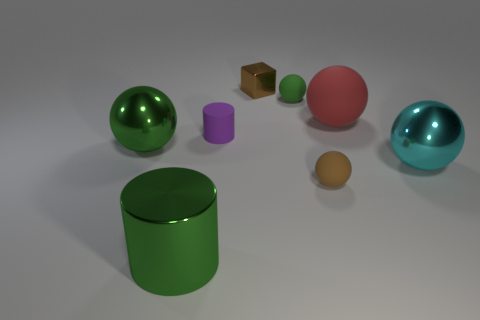What material is the big green object that is the same shape as the purple rubber thing?
Make the answer very short. Metal. Is the number of tiny purple rubber cylinders greater than the number of brown things?
Your response must be concise. No. How many other objects are the same color as the small block?
Provide a succinct answer. 1. Does the large red thing have the same material as the big sphere on the left side of the tiny brown rubber thing?
Your response must be concise. No. There is a small ball that is on the right side of the small matte ball that is behind the cyan metallic object; what number of metal objects are right of it?
Keep it short and to the point. 1. Is the number of cyan objects that are in front of the tiny purple matte object less than the number of metal objects that are on the right side of the green metallic ball?
Give a very brief answer. Yes. How many other things are the same material as the cyan object?
Your answer should be compact. 3. What material is the cyan sphere that is the same size as the green metal cylinder?
Offer a very short reply. Metal. How many purple things are either small spheres or rubber objects?
Your answer should be very brief. 1. What color is the thing that is on the right side of the small green rubber thing and behind the rubber cylinder?
Keep it short and to the point. Red. 